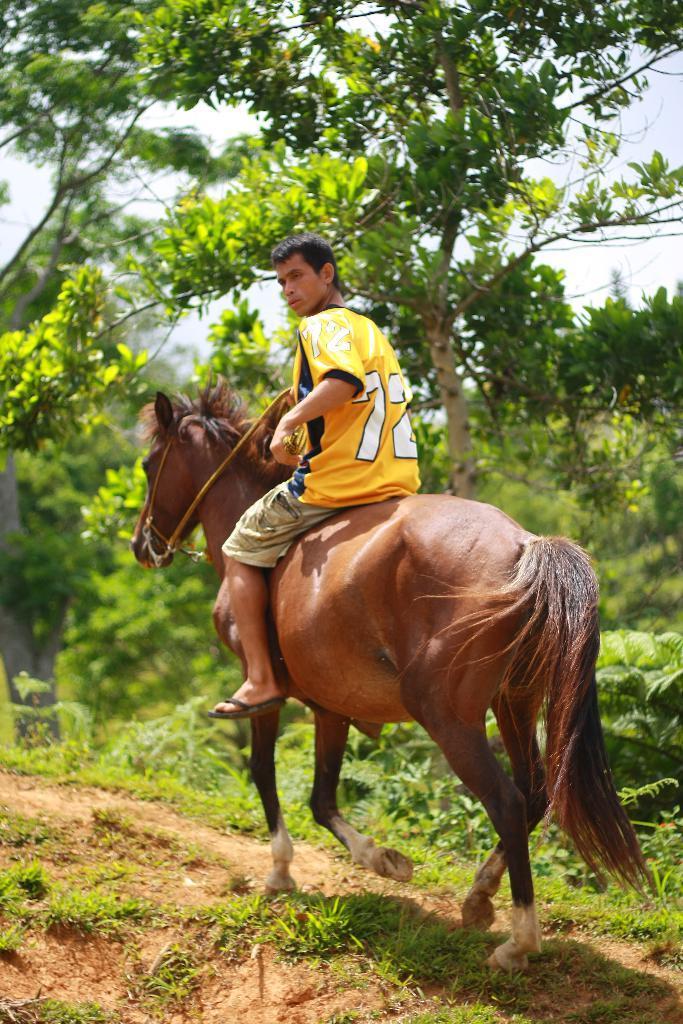Please provide a concise description of this image. In this picture in the middle one man is riding horse. The color of the horse is brown. The man is wearing yellow t shirt and shorts. In the ground there are grasses. In the background there are trees. This is the sky. the sky is clear. 